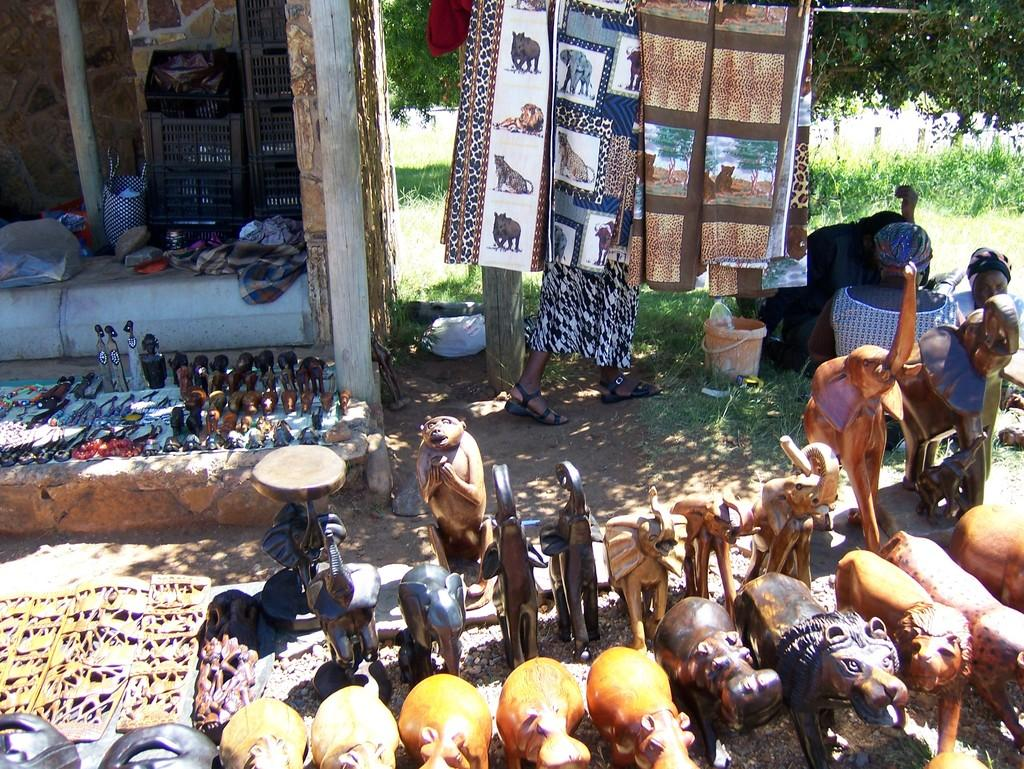What type of objects can be seen in the image that represent animals? There are animal statues in the image. What other items can be seen in the image? There are toys, a basket, and cloth in the image. What is the background of the image? There is a wall in the image. Are there any living organisms present in the image? Yes, there are people in the image. What type of vegetation can be seen in the image? There are plants and trees in the image. What time of day is it in the image, and how does it affect the agreement between the people? The time of day is not mentioned in the image, and there is no indication of an agreement between the people. How do the trees turn in the image? The trees do not turn in the image; they are stationary. 